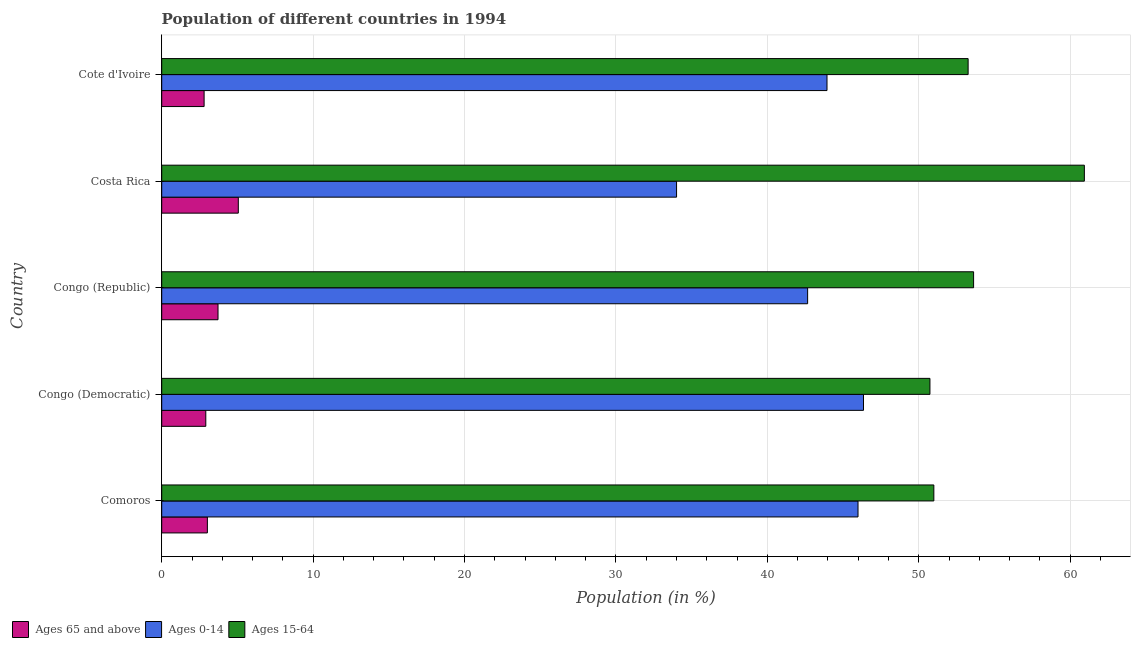Are the number of bars per tick equal to the number of legend labels?
Keep it short and to the point. Yes. Are the number of bars on each tick of the Y-axis equal?
Keep it short and to the point. Yes. What is the label of the 4th group of bars from the top?
Make the answer very short. Congo (Democratic). What is the percentage of population within the age-group of 65 and above in Congo (Republic)?
Your response must be concise. 3.72. Across all countries, what is the maximum percentage of population within the age-group of 65 and above?
Make the answer very short. 5.06. Across all countries, what is the minimum percentage of population within the age-group 0-14?
Ensure brevity in your answer.  34. In which country was the percentage of population within the age-group 15-64 maximum?
Ensure brevity in your answer.  Costa Rica. In which country was the percentage of population within the age-group of 65 and above minimum?
Your answer should be compact. Cote d'Ivoire. What is the total percentage of population within the age-group 15-64 in the graph?
Keep it short and to the point. 269.55. What is the difference between the percentage of population within the age-group 15-64 in Comoros and that in Congo (Republic)?
Ensure brevity in your answer.  -2.62. What is the difference between the percentage of population within the age-group 0-14 in Congo (Democratic) and the percentage of population within the age-group of 65 and above in Congo (Republic)?
Provide a succinct answer. 42.63. What is the average percentage of population within the age-group of 65 and above per country?
Your answer should be compact. 3.5. What is the difference between the percentage of population within the age-group 0-14 and percentage of population within the age-group of 65 and above in Costa Rica?
Provide a short and direct response. 28.95. In how many countries, is the percentage of population within the age-group 15-64 greater than 38 %?
Your answer should be very brief. 5. What is the ratio of the percentage of population within the age-group of 65 and above in Congo (Democratic) to that in Costa Rica?
Provide a short and direct response. 0.58. Is the difference between the percentage of population within the age-group 15-64 in Comoros and Cote d'Ivoire greater than the difference between the percentage of population within the age-group of 65 and above in Comoros and Cote d'Ivoire?
Provide a short and direct response. No. What is the difference between the highest and the second highest percentage of population within the age-group 15-64?
Make the answer very short. 7.32. What is the difference between the highest and the lowest percentage of population within the age-group of 65 and above?
Provide a short and direct response. 2.26. In how many countries, is the percentage of population within the age-group 0-14 greater than the average percentage of population within the age-group 0-14 taken over all countries?
Ensure brevity in your answer.  4. What does the 3rd bar from the top in Congo (Democratic) represents?
Your answer should be very brief. Ages 65 and above. What does the 2nd bar from the bottom in Costa Rica represents?
Give a very brief answer. Ages 0-14. Are all the bars in the graph horizontal?
Ensure brevity in your answer.  Yes. Where does the legend appear in the graph?
Give a very brief answer. Bottom left. How many legend labels are there?
Provide a short and direct response. 3. What is the title of the graph?
Provide a short and direct response. Population of different countries in 1994. Does "Argument" appear as one of the legend labels in the graph?
Ensure brevity in your answer.  No. What is the label or title of the X-axis?
Ensure brevity in your answer.  Population (in %). What is the label or title of the Y-axis?
Your answer should be compact. Country. What is the Population (in %) in Ages 65 and above in Comoros?
Provide a succinct answer. 3.02. What is the Population (in %) in Ages 0-14 in Comoros?
Your response must be concise. 45.99. What is the Population (in %) in Ages 15-64 in Comoros?
Give a very brief answer. 51. What is the Population (in %) in Ages 65 and above in Congo (Democratic)?
Provide a short and direct response. 2.91. What is the Population (in %) of Ages 0-14 in Congo (Democratic)?
Provide a succinct answer. 46.35. What is the Population (in %) in Ages 15-64 in Congo (Democratic)?
Ensure brevity in your answer.  50.74. What is the Population (in %) of Ages 65 and above in Congo (Republic)?
Make the answer very short. 3.72. What is the Population (in %) in Ages 0-14 in Congo (Republic)?
Offer a terse response. 42.66. What is the Population (in %) of Ages 15-64 in Congo (Republic)?
Make the answer very short. 53.62. What is the Population (in %) in Ages 65 and above in Costa Rica?
Provide a succinct answer. 5.06. What is the Population (in %) in Ages 0-14 in Costa Rica?
Provide a short and direct response. 34. What is the Population (in %) in Ages 15-64 in Costa Rica?
Offer a terse response. 60.94. What is the Population (in %) of Ages 65 and above in Cote d'Ivoire?
Offer a terse response. 2.8. What is the Population (in %) of Ages 0-14 in Cote d'Ivoire?
Offer a very short reply. 43.94. What is the Population (in %) of Ages 15-64 in Cote d'Ivoire?
Offer a terse response. 53.26. Across all countries, what is the maximum Population (in %) of Ages 65 and above?
Provide a succinct answer. 5.06. Across all countries, what is the maximum Population (in %) in Ages 0-14?
Your response must be concise. 46.35. Across all countries, what is the maximum Population (in %) of Ages 15-64?
Provide a short and direct response. 60.94. Across all countries, what is the minimum Population (in %) in Ages 65 and above?
Ensure brevity in your answer.  2.8. Across all countries, what is the minimum Population (in %) in Ages 0-14?
Your answer should be very brief. 34. Across all countries, what is the minimum Population (in %) of Ages 15-64?
Offer a very short reply. 50.74. What is the total Population (in %) in Ages 65 and above in the graph?
Give a very brief answer. 17.5. What is the total Population (in %) in Ages 0-14 in the graph?
Your answer should be very brief. 212.94. What is the total Population (in %) of Ages 15-64 in the graph?
Ensure brevity in your answer.  269.55. What is the difference between the Population (in %) of Ages 65 and above in Comoros and that in Congo (Democratic)?
Your response must be concise. 0.1. What is the difference between the Population (in %) in Ages 0-14 in Comoros and that in Congo (Democratic)?
Offer a terse response. -0.36. What is the difference between the Population (in %) in Ages 15-64 in Comoros and that in Congo (Democratic)?
Your answer should be compact. 0.26. What is the difference between the Population (in %) of Ages 65 and above in Comoros and that in Congo (Republic)?
Ensure brevity in your answer.  -0.7. What is the difference between the Population (in %) in Ages 0-14 in Comoros and that in Congo (Republic)?
Provide a short and direct response. 3.33. What is the difference between the Population (in %) of Ages 15-64 in Comoros and that in Congo (Republic)?
Your answer should be very brief. -2.62. What is the difference between the Population (in %) of Ages 65 and above in Comoros and that in Costa Rica?
Offer a terse response. -2.04. What is the difference between the Population (in %) of Ages 0-14 in Comoros and that in Costa Rica?
Provide a short and direct response. 11.98. What is the difference between the Population (in %) of Ages 15-64 in Comoros and that in Costa Rica?
Offer a terse response. -9.94. What is the difference between the Population (in %) in Ages 65 and above in Comoros and that in Cote d'Ivoire?
Your response must be concise. 0.22. What is the difference between the Population (in %) in Ages 0-14 in Comoros and that in Cote d'Ivoire?
Offer a very short reply. 2.05. What is the difference between the Population (in %) of Ages 15-64 in Comoros and that in Cote d'Ivoire?
Provide a succinct answer. -2.26. What is the difference between the Population (in %) of Ages 65 and above in Congo (Democratic) and that in Congo (Republic)?
Offer a very short reply. -0.81. What is the difference between the Population (in %) in Ages 0-14 in Congo (Democratic) and that in Congo (Republic)?
Make the answer very short. 3.69. What is the difference between the Population (in %) of Ages 15-64 in Congo (Democratic) and that in Congo (Republic)?
Ensure brevity in your answer.  -2.88. What is the difference between the Population (in %) in Ages 65 and above in Congo (Democratic) and that in Costa Rica?
Give a very brief answer. -2.15. What is the difference between the Population (in %) of Ages 0-14 in Congo (Democratic) and that in Costa Rica?
Ensure brevity in your answer.  12.35. What is the difference between the Population (in %) of Ages 15-64 in Congo (Democratic) and that in Costa Rica?
Offer a very short reply. -10.2. What is the difference between the Population (in %) in Ages 65 and above in Congo (Democratic) and that in Cote d'Ivoire?
Provide a succinct answer. 0.11. What is the difference between the Population (in %) of Ages 0-14 in Congo (Democratic) and that in Cote d'Ivoire?
Provide a short and direct response. 2.41. What is the difference between the Population (in %) in Ages 15-64 in Congo (Democratic) and that in Cote d'Ivoire?
Your answer should be very brief. -2.52. What is the difference between the Population (in %) in Ages 65 and above in Congo (Republic) and that in Costa Rica?
Provide a short and direct response. -1.34. What is the difference between the Population (in %) of Ages 0-14 in Congo (Republic) and that in Costa Rica?
Your answer should be compact. 8.66. What is the difference between the Population (in %) in Ages 15-64 in Congo (Republic) and that in Costa Rica?
Provide a succinct answer. -7.32. What is the difference between the Population (in %) in Ages 65 and above in Congo (Republic) and that in Cote d'Ivoire?
Your response must be concise. 0.92. What is the difference between the Population (in %) of Ages 0-14 in Congo (Republic) and that in Cote d'Ivoire?
Give a very brief answer. -1.28. What is the difference between the Population (in %) in Ages 15-64 in Congo (Republic) and that in Cote d'Ivoire?
Your response must be concise. 0.36. What is the difference between the Population (in %) of Ages 65 and above in Costa Rica and that in Cote d'Ivoire?
Your response must be concise. 2.26. What is the difference between the Population (in %) in Ages 0-14 in Costa Rica and that in Cote d'Ivoire?
Ensure brevity in your answer.  -9.94. What is the difference between the Population (in %) of Ages 15-64 in Costa Rica and that in Cote d'Ivoire?
Ensure brevity in your answer.  7.68. What is the difference between the Population (in %) of Ages 65 and above in Comoros and the Population (in %) of Ages 0-14 in Congo (Democratic)?
Your response must be concise. -43.34. What is the difference between the Population (in %) of Ages 65 and above in Comoros and the Population (in %) of Ages 15-64 in Congo (Democratic)?
Offer a very short reply. -47.72. What is the difference between the Population (in %) of Ages 0-14 in Comoros and the Population (in %) of Ages 15-64 in Congo (Democratic)?
Keep it short and to the point. -4.75. What is the difference between the Population (in %) of Ages 65 and above in Comoros and the Population (in %) of Ages 0-14 in Congo (Republic)?
Ensure brevity in your answer.  -39.64. What is the difference between the Population (in %) in Ages 65 and above in Comoros and the Population (in %) in Ages 15-64 in Congo (Republic)?
Offer a terse response. -50.61. What is the difference between the Population (in %) of Ages 0-14 in Comoros and the Population (in %) of Ages 15-64 in Congo (Republic)?
Provide a short and direct response. -7.63. What is the difference between the Population (in %) in Ages 65 and above in Comoros and the Population (in %) in Ages 0-14 in Costa Rica?
Keep it short and to the point. -30.99. What is the difference between the Population (in %) of Ages 65 and above in Comoros and the Population (in %) of Ages 15-64 in Costa Rica?
Ensure brevity in your answer.  -57.92. What is the difference between the Population (in %) of Ages 0-14 in Comoros and the Population (in %) of Ages 15-64 in Costa Rica?
Offer a terse response. -14.95. What is the difference between the Population (in %) of Ages 65 and above in Comoros and the Population (in %) of Ages 0-14 in Cote d'Ivoire?
Offer a terse response. -40.92. What is the difference between the Population (in %) of Ages 65 and above in Comoros and the Population (in %) of Ages 15-64 in Cote d'Ivoire?
Your answer should be compact. -50.24. What is the difference between the Population (in %) in Ages 0-14 in Comoros and the Population (in %) in Ages 15-64 in Cote d'Ivoire?
Provide a succinct answer. -7.27. What is the difference between the Population (in %) of Ages 65 and above in Congo (Democratic) and the Population (in %) of Ages 0-14 in Congo (Republic)?
Your answer should be very brief. -39.75. What is the difference between the Population (in %) of Ages 65 and above in Congo (Democratic) and the Population (in %) of Ages 15-64 in Congo (Republic)?
Provide a short and direct response. -50.71. What is the difference between the Population (in %) in Ages 0-14 in Congo (Democratic) and the Population (in %) in Ages 15-64 in Congo (Republic)?
Offer a very short reply. -7.27. What is the difference between the Population (in %) of Ages 65 and above in Congo (Democratic) and the Population (in %) of Ages 0-14 in Costa Rica?
Offer a terse response. -31.09. What is the difference between the Population (in %) in Ages 65 and above in Congo (Democratic) and the Population (in %) in Ages 15-64 in Costa Rica?
Your response must be concise. -58.03. What is the difference between the Population (in %) in Ages 0-14 in Congo (Democratic) and the Population (in %) in Ages 15-64 in Costa Rica?
Provide a succinct answer. -14.59. What is the difference between the Population (in %) of Ages 65 and above in Congo (Democratic) and the Population (in %) of Ages 0-14 in Cote d'Ivoire?
Your answer should be compact. -41.03. What is the difference between the Population (in %) in Ages 65 and above in Congo (Democratic) and the Population (in %) in Ages 15-64 in Cote d'Ivoire?
Your answer should be very brief. -50.35. What is the difference between the Population (in %) of Ages 0-14 in Congo (Democratic) and the Population (in %) of Ages 15-64 in Cote d'Ivoire?
Make the answer very short. -6.91. What is the difference between the Population (in %) in Ages 65 and above in Congo (Republic) and the Population (in %) in Ages 0-14 in Costa Rica?
Keep it short and to the point. -30.29. What is the difference between the Population (in %) of Ages 65 and above in Congo (Republic) and the Population (in %) of Ages 15-64 in Costa Rica?
Offer a terse response. -57.22. What is the difference between the Population (in %) in Ages 0-14 in Congo (Republic) and the Population (in %) in Ages 15-64 in Costa Rica?
Keep it short and to the point. -18.28. What is the difference between the Population (in %) of Ages 65 and above in Congo (Republic) and the Population (in %) of Ages 0-14 in Cote d'Ivoire?
Provide a short and direct response. -40.22. What is the difference between the Population (in %) of Ages 65 and above in Congo (Republic) and the Population (in %) of Ages 15-64 in Cote d'Ivoire?
Keep it short and to the point. -49.54. What is the difference between the Population (in %) of Ages 65 and above in Costa Rica and the Population (in %) of Ages 0-14 in Cote d'Ivoire?
Your response must be concise. -38.88. What is the difference between the Population (in %) of Ages 65 and above in Costa Rica and the Population (in %) of Ages 15-64 in Cote d'Ivoire?
Provide a short and direct response. -48.2. What is the difference between the Population (in %) in Ages 0-14 in Costa Rica and the Population (in %) in Ages 15-64 in Cote d'Ivoire?
Make the answer very short. -19.26. What is the average Population (in %) in Ages 65 and above per country?
Give a very brief answer. 3.5. What is the average Population (in %) of Ages 0-14 per country?
Provide a succinct answer. 42.59. What is the average Population (in %) in Ages 15-64 per country?
Provide a succinct answer. 53.91. What is the difference between the Population (in %) of Ages 65 and above and Population (in %) of Ages 0-14 in Comoros?
Offer a terse response. -42.97. What is the difference between the Population (in %) of Ages 65 and above and Population (in %) of Ages 15-64 in Comoros?
Ensure brevity in your answer.  -47.98. What is the difference between the Population (in %) of Ages 0-14 and Population (in %) of Ages 15-64 in Comoros?
Give a very brief answer. -5.01. What is the difference between the Population (in %) of Ages 65 and above and Population (in %) of Ages 0-14 in Congo (Democratic)?
Make the answer very short. -43.44. What is the difference between the Population (in %) in Ages 65 and above and Population (in %) in Ages 15-64 in Congo (Democratic)?
Your response must be concise. -47.83. What is the difference between the Population (in %) in Ages 0-14 and Population (in %) in Ages 15-64 in Congo (Democratic)?
Your answer should be very brief. -4.39. What is the difference between the Population (in %) in Ages 65 and above and Population (in %) in Ages 0-14 in Congo (Republic)?
Make the answer very short. -38.94. What is the difference between the Population (in %) in Ages 65 and above and Population (in %) in Ages 15-64 in Congo (Republic)?
Give a very brief answer. -49.9. What is the difference between the Population (in %) of Ages 0-14 and Population (in %) of Ages 15-64 in Congo (Republic)?
Provide a short and direct response. -10.96. What is the difference between the Population (in %) of Ages 65 and above and Population (in %) of Ages 0-14 in Costa Rica?
Provide a short and direct response. -28.95. What is the difference between the Population (in %) of Ages 65 and above and Population (in %) of Ages 15-64 in Costa Rica?
Offer a terse response. -55.88. What is the difference between the Population (in %) in Ages 0-14 and Population (in %) in Ages 15-64 in Costa Rica?
Provide a succinct answer. -26.93. What is the difference between the Population (in %) in Ages 65 and above and Population (in %) in Ages 0-14 in Cote d'Ivoire?
Offer a terse response. -41.14. What is the difference between the Population (in %) in Ages 65 and above and Population (in %) in Ages 15-64 in Cote d'Ivoire?
Give a very brief answer. -50.46. What is the difference between the Population (in %) of Ages 0-14 and Population (in %) of Ages 15-64 in Cote d'Ivoire?
Make the answer very short. -9.32. What is the ratio of the Population (in %) of Ages 65 and above in Comoros to that in Congo (Democratic)?
Offer a very short reply. 1.04. What is the ratio of the Population (in %) of Ages 0-14 in Comoros to that in Congo (Democratic)?
Provide a short and direct response. 0.99. What is the ratio of the Population (in %) of Ages 15-64 in Comoros to that in Congo (Democratic)?
Provide a succinct answer. 1.01. What is the ratio of the Population (in %) of Ages 65 and above in Comoros to that in Congo (Republic)?
Your answer should be very brief. 0.81. What is the ratio of the Population (in %) of Ages 0-14 in Comoros to that in Congo (Republic)?
Offer a very short reply. 1.08. What is the ratio of the Population (in %) of Ages 15-64 in Comoros to that in Congo (Republic)?
Offer a very short reply. 0.95. What is the ratio of the Population (in %) of Ages 65 and above in Comoros to that in Costa Rica?
Keep it short and to the point. 0.6. What is the ratio of the Population (in %) in Ages 0-14 in Comoros to that in Costa Rica?
Your response must be concise. 1.35. What is the ratio of the Population (in %) of Ages 15-64 in Comoros to that in Costa Rica?
Ensure brevity in your answer.  0.84. What is the ratio of the Population (in %) in Ages 65 and above in Comoros to that in Cote d'Ivoire?
Provide a succinct answer. 1.08. What is the ratio of the Population (in %) in Ages 0-14 in Comoros to that in Cote d'Ivoire?
Offer a terse response. 1.05. What is the ratio of the Population (in %) of Ages 15-64 in Comoros to that in Cote d'Ivoire?
Offer a terse response. 0.96. What is the ratio of the Population (in %) in Ages 65 and above in Congo (Democratic) to that in Congo (Republic)?
Give a very brief answer. 0.78. What is the ratio of the Population (in %) of Ages 0-14 in Congo (Democratic) to that in Congo (Republic)?
Offer a terse response. 1.09. What is the ratio of the Population (in %) in Ages 15-64 in Congo (Democratic) to that in Congo (Republic)?
Give a very brief answer. 0.95. What is the ratio of the Population (in %) in Ages 65 and above in Congo (Democratic) to that in Costa Rica?
Ensure brevity in your answer.  0.58. What is the ratio of the Population (in %) of Ages 0-14 in Congo (Democratic) to that in Costa Rica?
Provide a short and direct response. 1.36. What is the ratio of the Population (in %) of Ages 15-64 in Congo (Democratic) to that in Costa Rica?
Make the answer very short. 0.83. What is the ratio of the Population (in %) of Ages 65 and above in Congo (Democratic) to that in Cote d'Ivoire?
Keep it short and to the point. 1.04. What is the ratio of the Population (in %) of Ages 0-14 in Congo (Democratic) to that in Cote d'Ivoire?
Ensure brevity in your answer.  1.05. What is the ratio of the Population (in %) in Ages 15-64 in Congo (Democratic) to that in Cote d'Ivoire?
Make the answer very short. 0.95. What is the ratio of the Population (in %) in Ages 65 and above in Congo (Republic) to that in Costa Rica?
Your answer should be compact. 0.74. What is the ratio of the Population (in %) of Ages 0-14 in Congo (Republic) to that in Costa Rica?
Your answer should be very brief. 1.25. What is the ratio of the Population (in %) of Ages 15-64 in Congo (Republic) to that in Costa Rica?
Offer a terse response. 0.88. What is the ratio of the Population (in %) in Ages 65 and above in Congo (Republic) to that in Cote d'Ivoire?
Ensure brevity in your answer.  1.33. What is the ratio of the Population (in %) of Ages 0-14 in Congo (Republic) to that in Cote d'Ivoire?
Provide a succinct answer. 0.97. What is the ratio of the Population (in %) in Ages 15-64 in Congo (Republic) to that in Cote d'Ivoire?
Your answer should be very brief. 1.01. What is the ratio of the Population (in %) in Ages 65 and above in Costa Rica to that in Cote d'Ivoire?
Provide a short and direct response. 1.81. What is the ratio of the Population (in %) in Ages 0-14 in Costa Rica to that in Cote d'Ivoire?
Make the answer very short. 0.77. What is the ratio of the Population (in %) in Ages 15-64 in Costa Rica to that in Cote d'Ivoire?
Your answer should be very brief. 1.14. What is the difference between the highest and the second highest Population (in %) in Ages 65 and above?
Offer a terse response. 1.34. What is the difference between the highest and the second highest Population (in %) of Ages 0-14?
Your answer should be very brief. 0.36. What is the difference between the highest and the second highest Population (in %) in Ages 15-64?
Make the answer very short. 7.32. What is the difference between the highest and the lowest Population (in %) of Ages 65 and above?
Keep it short and to the point. 2.26. What is the difference between the highest and the lowest Population (in %) in Ages 0-14?
Offer a very short reply. 12.35. What is the difference between the highest and the lowest Population (in %) of Ages 15-64?
Ensure brevity in your answer.  10.2. 